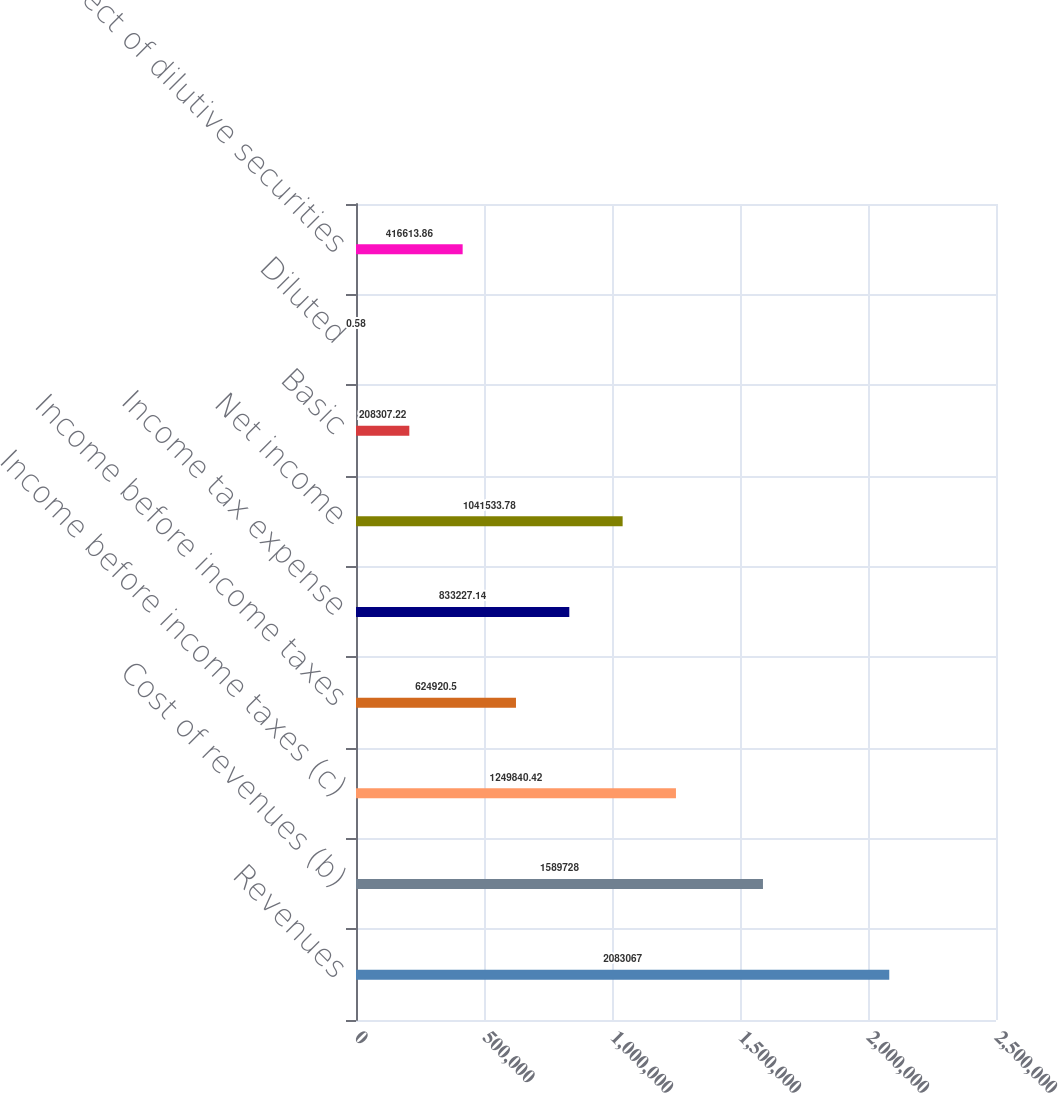<chart> <loc_0><loc_0><loc_500><loc_500><bar_chart><fcel>Revenues<fcel>Cost of revenues (b)<fcel>Income before income taxes (c)<fcel>Income before income taxes<fcel>Income tax expense<fcel>Net income<fcel>Basic<fcel>Diluted<fcel>Effect of dilutive securities<nl><fcel>2.08307e+06<fcel>1.58973e+06<fcel>1.24984e+06<fcel>624920<fcel>833227<fcel>1.04153e+06<fcel>208307<fcel>0.58<fcel>416614<nl></chart> 